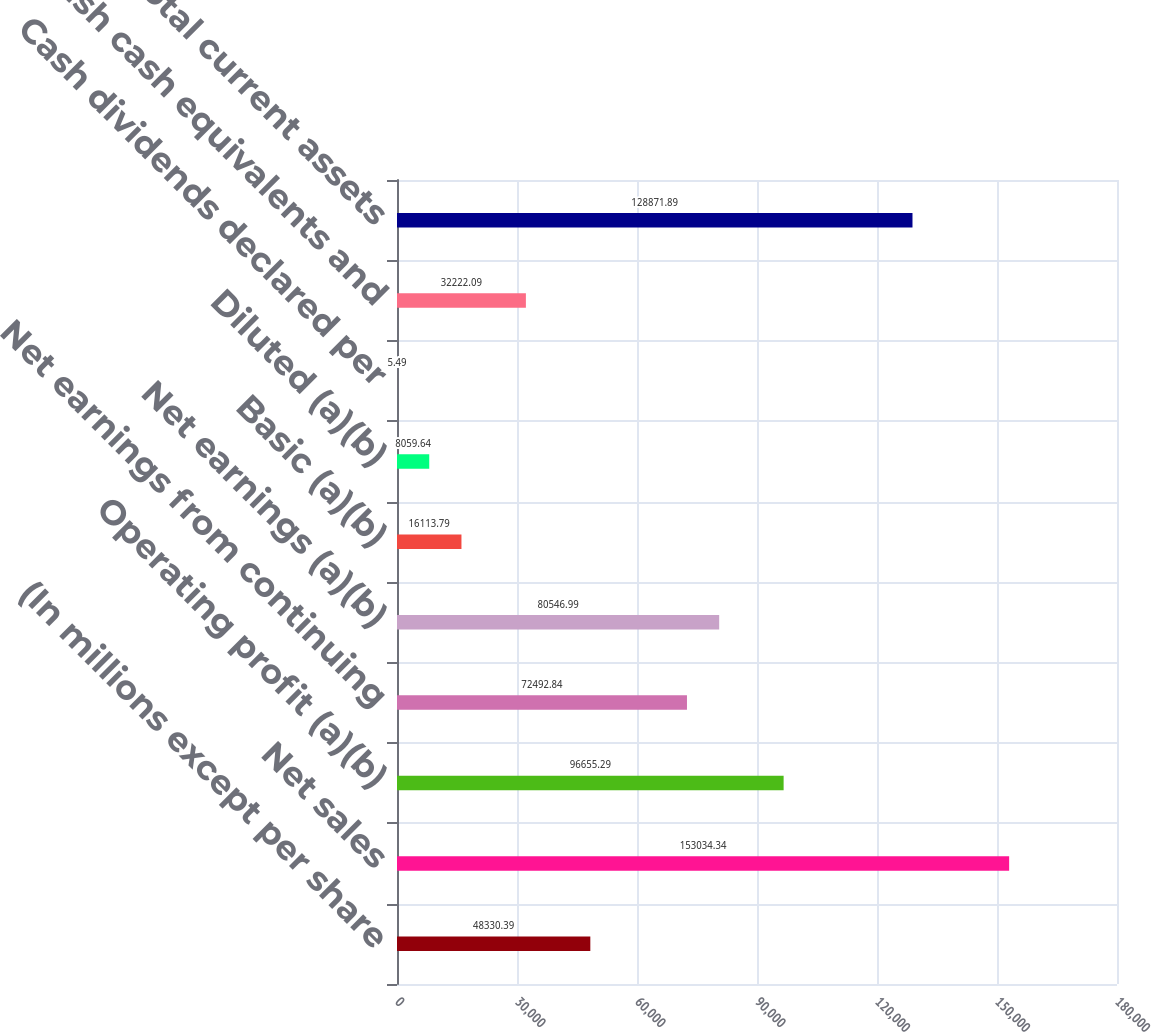Convert chart to OTSL. <chart><loc_0><loc_0><loc_500><loc_500><bar_chart><fcel>(In millions except per share<fcel>Net sales<fcel>Operating profit (a)(b)<fcel>Net earnings from continuing<fcel>Net earnings (a)(b)<fcel>Basic (a)(b)<fcel>Diluted (a)(b)<fcel>Cash dividends declared per<fcel>Cash cash equivalents and<fcel>Total current assets<nl><fcel>48330.4<fcel>153034<fcel>96655.3<fcel>72492.8<fcel>80547<fcel>16113.8<fcel>8059.64<fcel>5.49<fcel>32222.1<fcel>128872<nl></chart> 